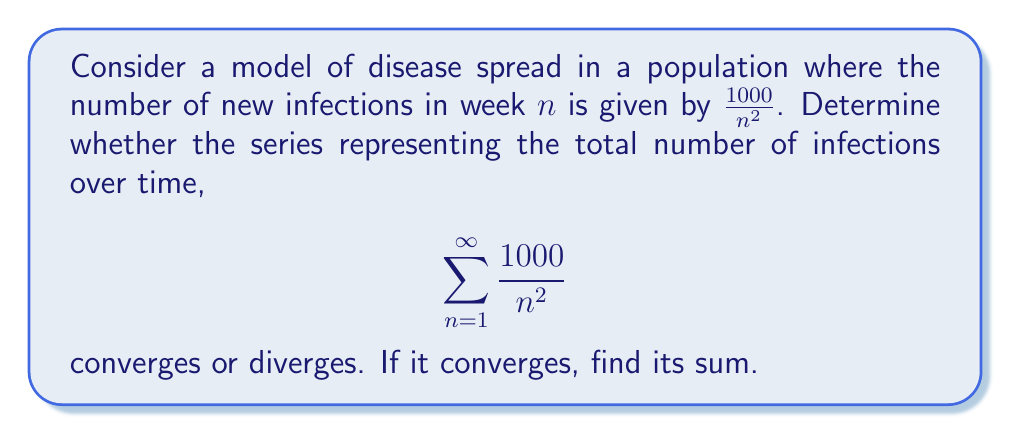Show me your answer to this math problem. To determine the convergence of this series, we can use the p-series test and compare it to the Riemann zeta function.

1) First, we recognize that this series is in the form of a p-series:

   $$\sum_{n=1}^{\infty} \frac{a}{n^p}$$

   where $a = 1000$ and $p = 2$.

2) For a p-series, we know that:
   - If $p > 1$, the series converges
   - If $p \leq 1$, the series diverges

3) In this case, $p = 2 > 1$, so the series converges.

4) To find the sum, we can relate this to the Riemann zeta function:

   $$\zeta(2) = \sum_{n=1}^{\infty} \frac{1}{n^2} = \frac{\pi^2}{6}$$

5) Our series is 1000 times this sum:

   $$1000 \sum_{n=1}^{\infty} \frac{1}{n^2} = 1000 \cdot \frac{\pi^2}{6}$$

6) Calculate the final result:

   $$1000 \cdot \frac{\pi^2}{6} \approx 1644.93$$

From an epidemiological perspective, this result suggests that the total number of infections over an infinite time period would be finite, approaching approximately 1645 cases. This could represent a disease with a decreasing transmission rate over time, possibly due to interventions or increasing population immunity.
Answer: The series converges. Its sum is $\frac{1000\pi^2}{6} \approx 1644.93$. 